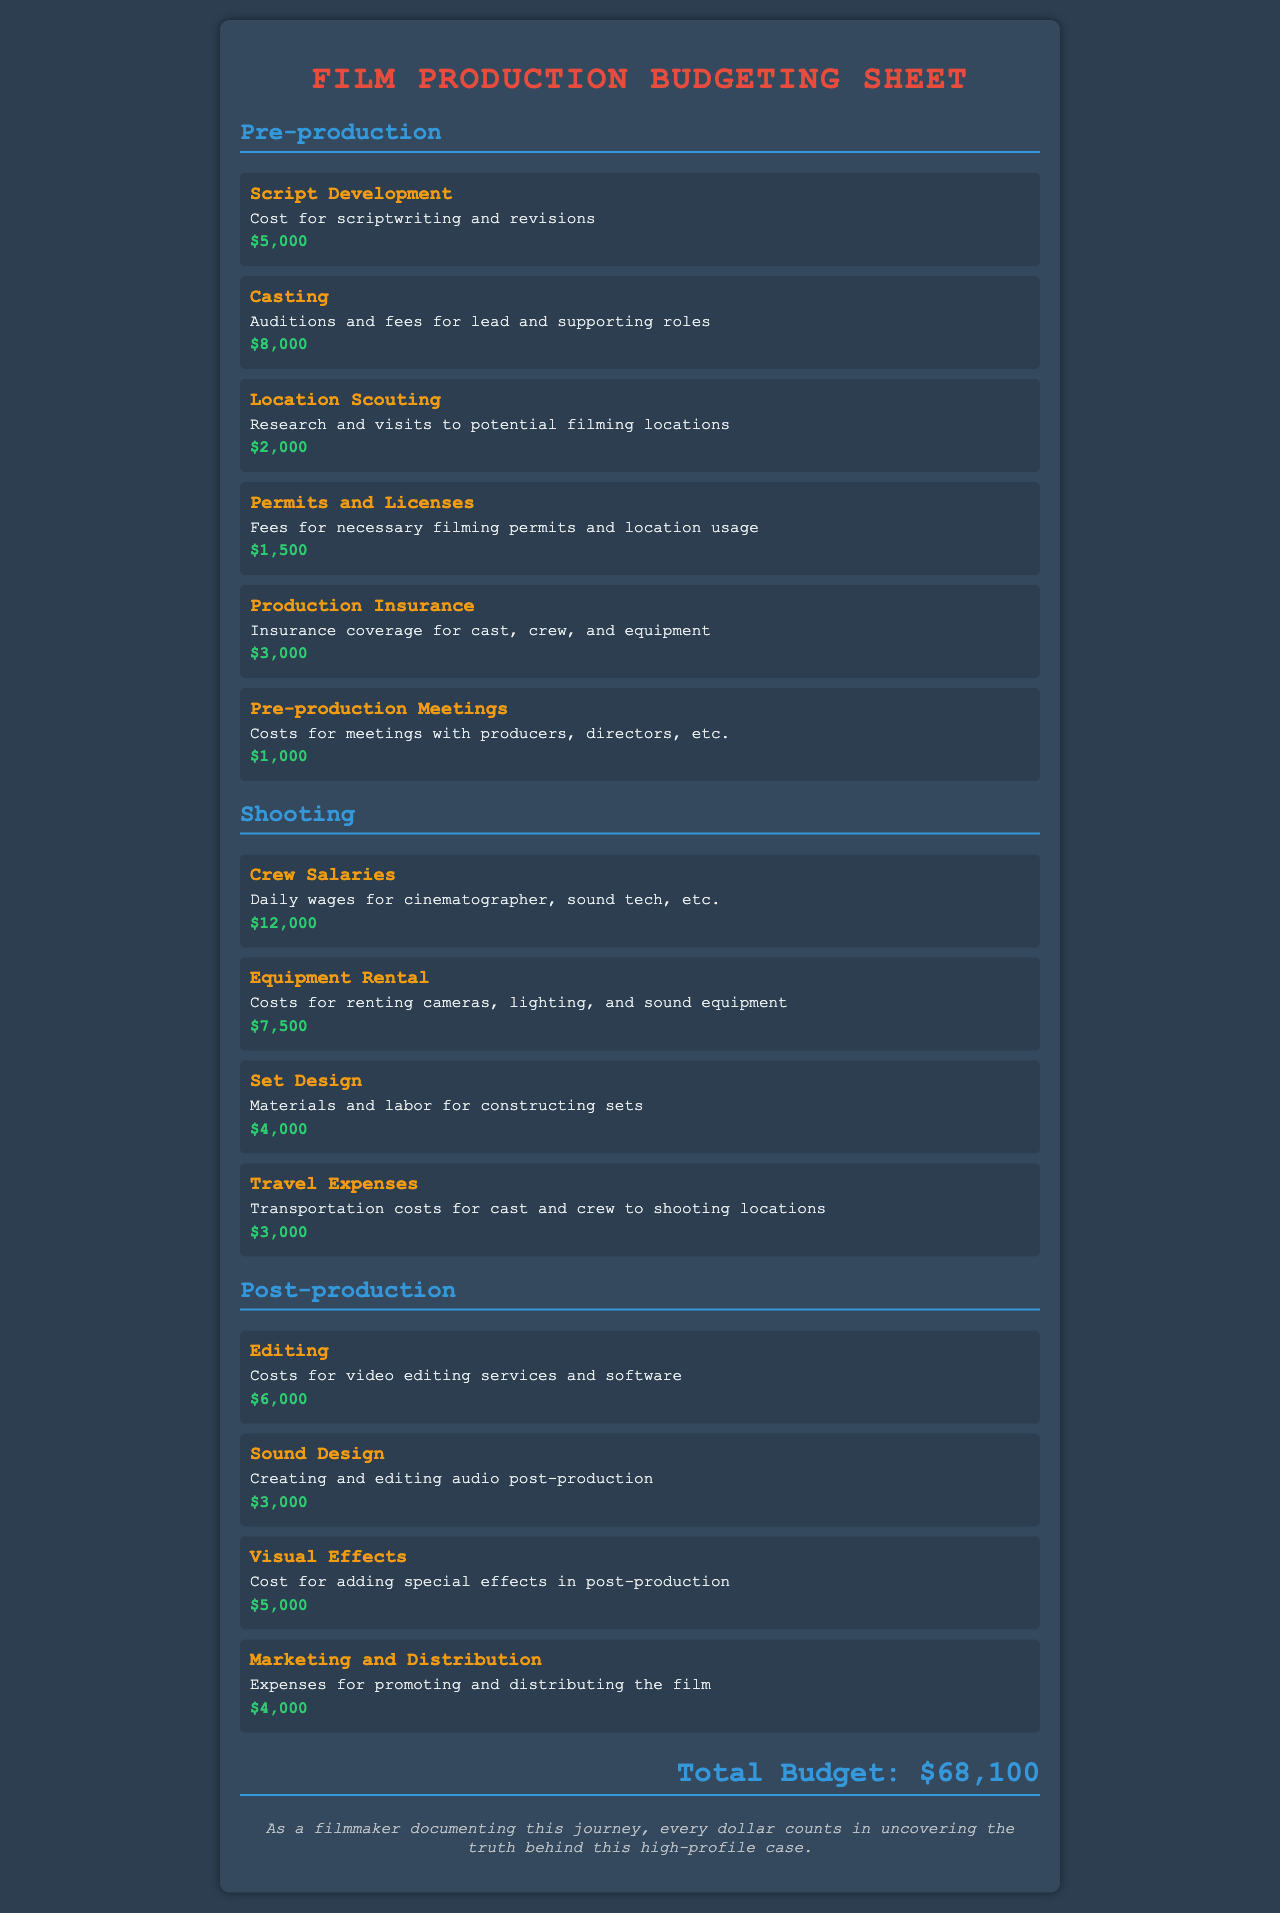What is the total budget? The total budget is explicitly stated at the end of the document, combining all the listed expenses.
Answer: $68,100 How much is allocated for casting? The casting expense is listed under the pre-production section with its specific cost noted.
Answer: $8,000 What is the cost for sound design? The document specifies the cost for sound design under post-production.
Answer: $3,000 What is the expense for equipment rental? The equipment rental cost is detailed in the shooting section of the budget.
Answer: $7,500 What are the total expenses for pre-production? Pre-production costs are summed by adding all expenses listed in that section of the document.
Answer: $20,500 Which pre-production item has the lowest cost? The item costs are compared to identify the one with the least expense in pre-production.
Answer: Location Scouting What is the expense associated with marketing and distribution? The final budgeting line in post-production identifies this specific cost.
Answer: $4,000 How much is spent on visual effects? The visual effects expense is clearly mentioned under post-production expenses.
Answer: $5,000 What is the purpose of production insurance? This item is described in detail, explaining the coverage it provides during production.
Answer: Insurance coverage for cast, crew, and equipment 